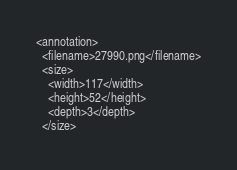Convert code to text. <code><loc_0><loc_0><loc_500><loc_500><_XML_><annotation>
  <filename>27990.png</filename>
  <size>
    <width>117</width>
    <height>52</height>
    <depth>3</depth>
  </size></code> 